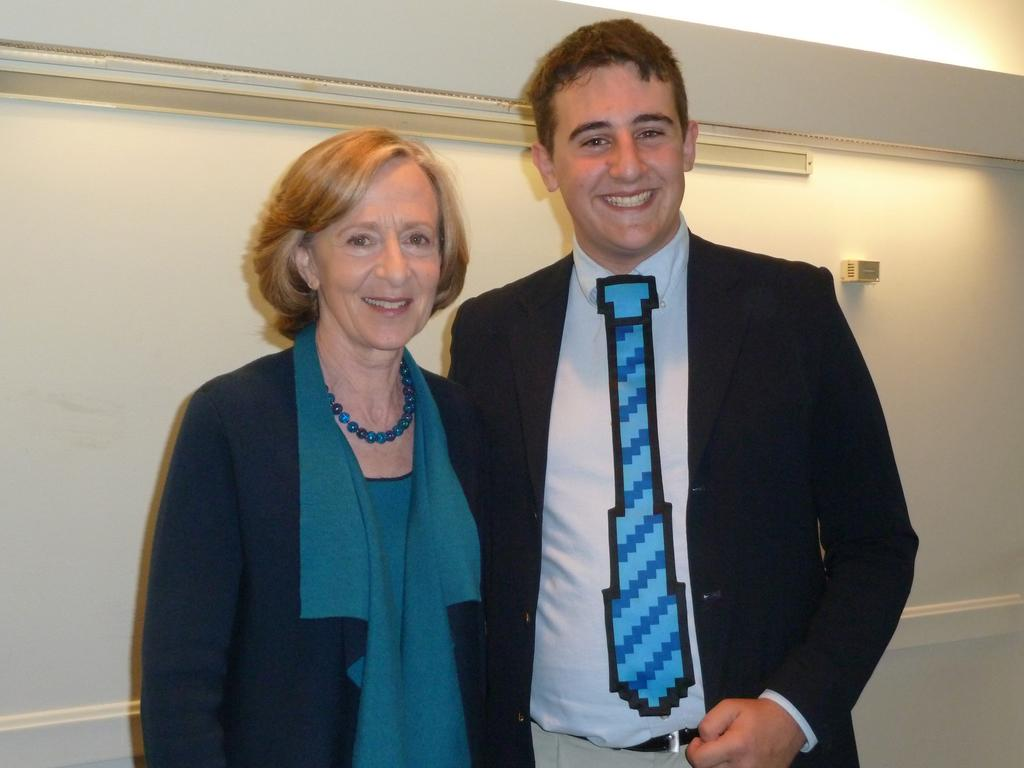Who can be seen in the image? There is a lady and a man in the image. What are the lady and the man doing in the image? Both the lady and the man are standing in the image. What are they wearing? They are both wearing coats. What expression do they have on their faces? They are both smiling. What can be seen in the background of the image? There is a wall in the background of the image. What type of chess game are they playing in the image? There is no chess game present in the image; the lady and the man are simply standing and smiling. 